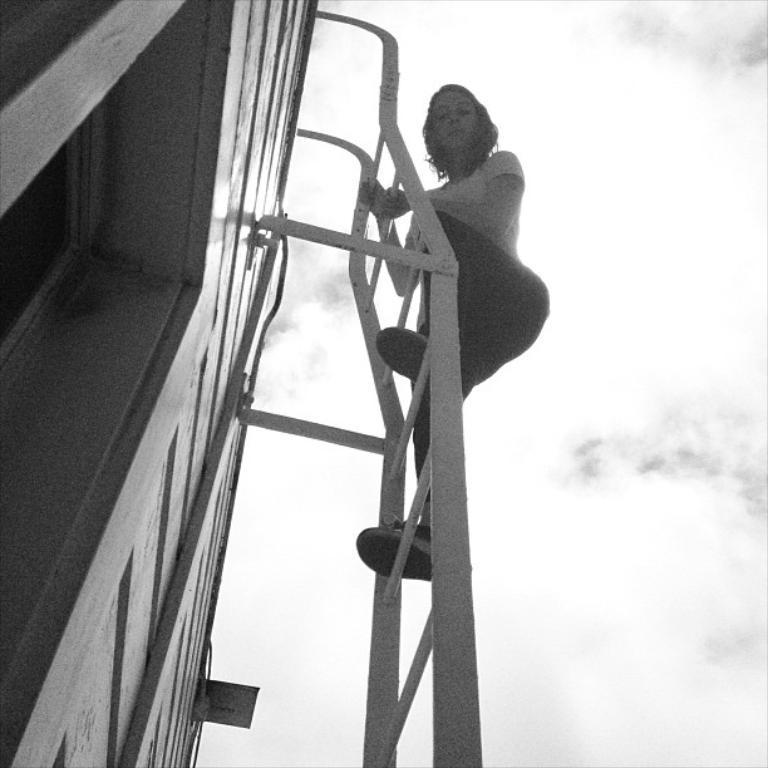Could you give a brief overview of what you see in this image? In this black and white picture a woman is standing on the ladder which is attached to the wall. Right side there is sky with some clouds. 